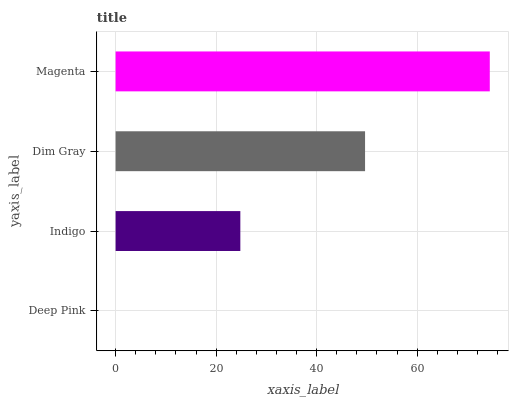Is Deep Pink the minimum?
Answer yes or no. Yes. Is Magenta the maximum?
Answer yes or no. Yes. Is Indigo the minimum?
Answer yes or no. No. Is Indigo the maximum?
Answer yes or no. No. Is Indigo greater than Deep Pink?
Answer yes or no. Yes. Is Deep Pink less than Indigo?
Answer yes or no. Yes. Is Deep Pink greater than Indigo?
Answer yes or no. No. Is Indigo less than Deep Pink?
Answer yes or no. No. Is Dim Gray the high median?
Answer yes or no. Yes. Is Indigo the low median?
Answer yes or no. Yes. Is Deep Pink the high median?
Answer yes or no. No. Is Deep Pink the low median?
Answer yes or no. No. 